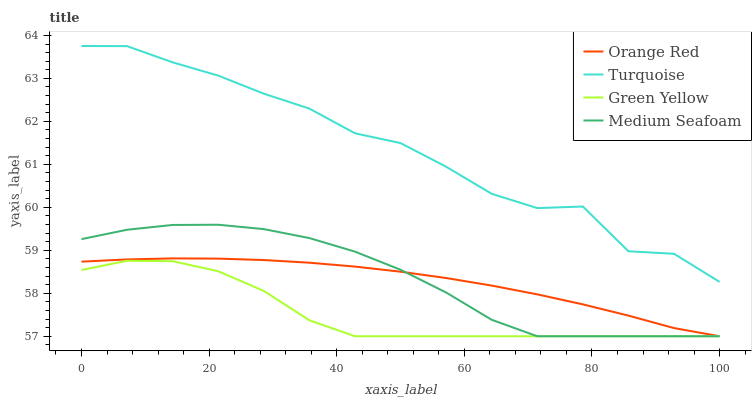Does Orange Red have the minimum area under the curve?
Answer yes or no. No. Does Orange Red have the maximum area under the curve?
Answer yes or no. No. Is Green Yellow the smoothest?
Answer yes or no. No. Is Green Yellow the roughest?
Answer yes or no. No. Does Orange Red have the highest value?
Answer yes or no. No. Is Green Yellow less than Turquoise?
Answer yes or no. Yes. Is Turquoise greater than Orange Red?
Answer yes or no. Yes. Does Green Yellow intersect Turquoise?
Answer yes or no. No. 